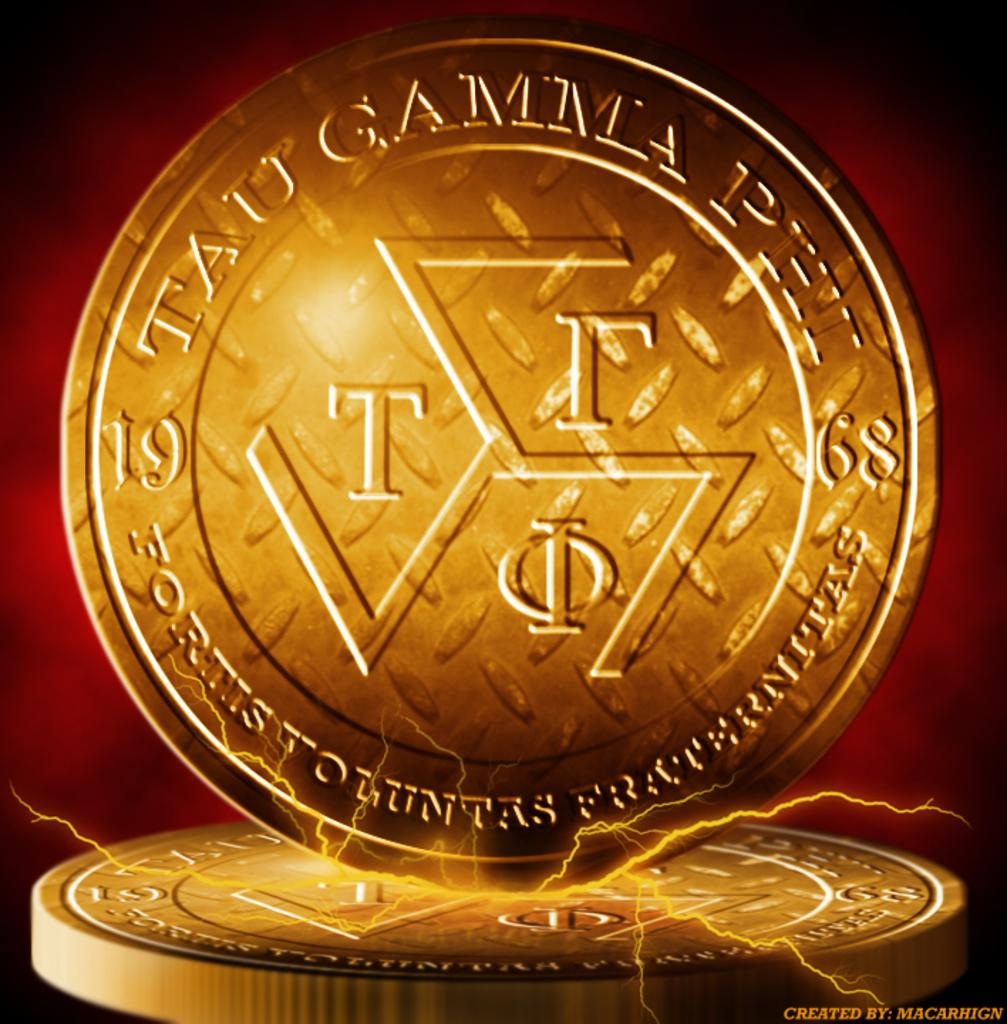<image>
Present a compact description of the photo's key features. A graphic of a coin with Greek lettering sits on another coin. 